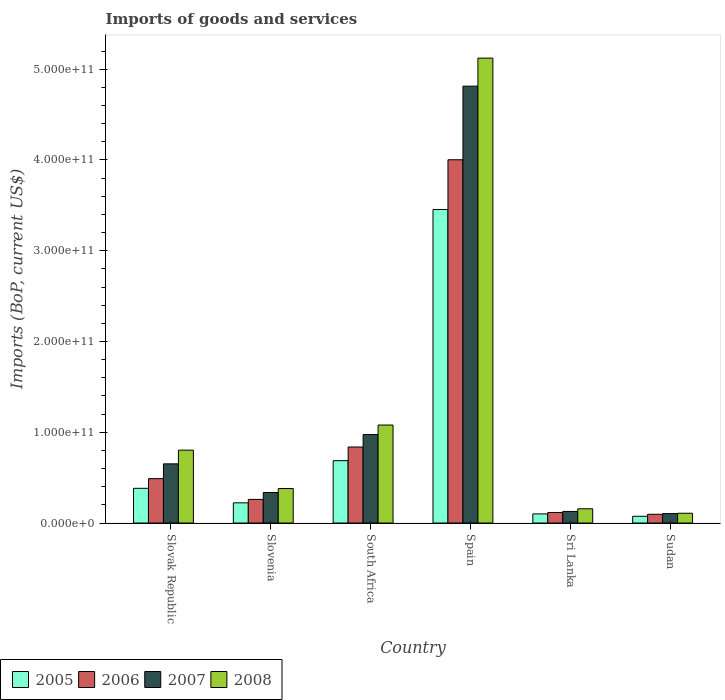How many groups of bars are there?
Ensure brevity in your answer.  6. Are the number of bars on each tick of the X-axis equal?
Provide a succinct answer. Yes. How many bars are there on the 6th tick from the left?
Your response must be concise. 4. What is the label of the 5th group of bars from the left?
Your answer should be compact. Sri Lanka. What is the amount spent on imports in 2006 in Sri Lanka?
Your answer should be very brief. 1.16e+1. Across all countries, what is the maximum amount spent on imports in 2008?
Provide a succinct answer. 5.12e+11. Across all countries, what is the minimum amount spent on imports in 2005?
Your response must be concise. 7.45e+09. In which country was the amount spent on imports in 2005 maximum?
Your response must be concise. Spain. In which country was the amount spent on imports in 2006 minimum?
Offer a very short reply. Sudan. What is the total amount spent on imports in 2008 in the graph?
Make the answer very short. 7.65e+11. What is the difference between the amount spent on imports in 2008 in South Africa and that in Sudan?
Ensure brevity in your answer.  9.72e+1. What is the difference between the amount spent on imports in 2008 in Sudan and the amount spent on imports in 2006 in Slovenia?
Offer a terse response. -1.53e+1. What is the average amount spent on imports in 2005 per country?
Your response must be concise. 8.20e+1. What is the difference between the amount spent on imports of/in 2007 and amount spent on imports of/in 2006 in Slovenia?
Provide a short and direct response. 7.59e+09. What is the ratio of the amount spent on imports in 2006 in Spain to that in Sri Lanka?
Offer a terse response. 34.44. What is the difference between the highest and the second highest amount spent on imports in 2008?
Provide a succinct answer. 4.04e+11. What is the difference between the highest and the lowest amount spent on imports in 2007?
Give a very brief answer. 4.71e+11. In how many countries, is the amount spent on imports in 2008 greater than the average amount spent on imports in 2008 taken over all countries?
Offer a terse response. 1. Is the sum of the amount spent on imports in 2006 in Slovak Republic and Sri Lanka greater than the maximum amount spent on imports in 2007 across all countries?
Keep it short and to the point. No. Is it the case that in every country, the sum of the amount spent on imports in 2008 and amount spent on imports in 2006 is greater than the sum of amount spent on imports in 2005 and amount spent on imports in 2007?
Provide a short and direct response. No. What does the 2nd bar from the right in Slovenia represents?
Provide a short and direct response. 2007. How many bars are there?
Your response must be concise. 24. Are all the bars in the graph horizontal?
Your response must be concise. No. How many countries are there in the graph?
Offer a very short reply. 6. What is the difference between two consecutive major ticks on the Y-axis?
Your answer should be very brief. 1.00e+11. Are the values on the major ticks of Y-axis written in scientific E-notation?
Your answer should be compact. Yes. How many legend labels are there?
Your response must be concise. 4. How are the legend labels stacked?
Provide a short and direct response. Horizontal. What is the title of the graph?
Provide a succinct answer. Imports of goods and services. Does "2002" appear as one of the legend labels in the graph?
Your response must be concise. No. What is the label or title of the Y-axis?
Make the answer very short. Imports (BoP, current US$). What is the Imports (BoP, current US$) in 2005 in Slovak Republic?
Your answer should be very brief. 3.82e+1. What is the Imports (BoP, current US$) of 2006 in Slovak Republic?
Your response must be concise. 4.89e+1. What is the Imports (BoP, current US$) in 2007 in Slovak Republic?
Keep it short and to the point. 6.52e+1. What is the Imports (BoP, current US$) of 2008 in Slovak Republic?
Provide a succinct answer. 8.03e+1. What is the Imports (BoP, current US$) of 2005 in Slovenia?
Make the answer very short. 2.22e+1. What is the Imports (BoP, current US$) in 2006 in Slovenia?
Ensure brevity in your answer.  2.60e+1. What is the Imports (BoP, current US$) in 2007 in Slovenia?
Your answer should be compact. 3.36e+1. What is the Imports (BoP, current US$) of 2008 in Slovenia?
Keep it short and to the point. 3.80e+1. What is the Imports (BoP, current US$) in 2005 in South Africa?
Provide a succinct answer. 6.87e+1. What is the Imports (BoP, current US$) in 2006 in South Africa?
Your answer should be compact. 8.38e+1. What is the Imports (BoP, current US$) in 2007 in South Africa?
Ensure brevity in your answer.  9.75e+1. What is the Imports (BoP, current US$) of 2008 in South Africa?
Your response must be concise. 1.08e+11. What is the Imports (BoP, current US$) in 2005 in Spain?
Offer a very short reply. 3.45e+11. What is the Imports (BoP, current US$) of 2006 in Spain?
Ensure brevity in your answer.  4.00e+11. What is the Imports (BoP, current US$) of 2007 in Spain?
Ensure brevity in your answer.  4.81e+11. What is the Imports (BoP, current US$) of 2008 in Spain?
Offer a terse response. 5.12e+11. What is the Imports (BoP, current US$) in 2005 in Sri Lanka?
Offer a terse response. 1.01e+1. What is the Imports (BoP, current US$) in 2006 in Sri Lanka?
Ensure brevity in your answer.  1.16e+1. What is the Imports (BoP, current US$) in 2007 in Sri Lanka?
Give a very brief answer. 1.28e+1. What is the Imports (BoP, current US$) of 2008 in Sri Lanka?
Offer a terse response. 1.57e+1. What is the Imports (BoP, current US$) in 2005 in Sudan?
Make the answer very short. 7.45e+09. What is the Imports (BoP, current US$) in 2006 in Sudan?
Provide a succinct answer. 9.63e+09. What is the Imports (BoP, current US$) in 2007 in Sudan?
Your answer should be compact. 1.04e+1. What is the Imports (BoP, current US$) of 2008 in Sudan?
Your answer should be very brief. 1.08e+1. Across all countries, what is the maximum Imports (BoP, current US$) of 2005?
Offer a very short reply. 3.45e+11. Across all countries, what is the maximum Imports (BoP, current US$) of 2006?
Your answer should be very brief. 4.00e+11. Across all countries, what is the maximum Imports (BoP, current US$) in 2007?
Provide a succinct answer. 4.81e+11. Across all countries, what is the maximum Imports (BoP, current US$) of 2008?
Provide a short and direct response. 5.12e+11. Across all countries, what is the minimum Imports (BoP, current US$) of 2005?
Provide a short and direct response. 7.45e+09. Across all countries, what is the minimum Imports (BoP, current US$) of 2006?
Provide a succinct answer. 9.63e+09. Across all countries, what is the minimum Imports (BoP, current US$) in 2007?
Your answer should be very brief. 1.04e+1. Across all countries, what is the minimum Imports (BoP, current US$) of 2008?
Give a very brief answer. 1.08e+1. What is the total Imports (BoP, current US$) in 2005 in the graph?
Make the answer very short. 4.92e+11. What is the total Imports (BoP, current US$) in 2006 in the graph?
Your answer should be compact. 5.80e+11. What is the total Imports (BoP, current US$) in 2007 in the graph?
Your answer should be very brief. 7.01e+11. What is the total Imports (BoP, current US$) in 2008 in the graph?
Make the answer very short. 7.65e+11. What is the difference between the Imports (BoP, current US$) of 2005 in Slovak Republic and that in Slovenia?
Make the answer very short. 1.60e+1. What is the difference between the Imports (BoP, current US$) in 2006 in Slovak Republic and that in Slovenia?
Provide a succinct answer. 2.29e+1. What is the difference between the Imports (BoP, current US$) of 2007 in Slovak Republic and that in Slovenia?
Keep it short and to the point. 3.16e+1. What is the difference between the Imports (BoP, current US$) in 2008 in Slovak Republic and that in Slovenia?
Ensure brevity in your answer.  4.23e+1. What is the difference between the Imports (BoP, current US$) of 2005 in Slovak Republic and that in South Africa?
Your response must be concise. -3.05e+1. What is the difference between the Imports (BoP, current US$) in 2006 in Slovak Republic and that in South Africa?
Give a very brief answer. -3.49e+1. What is the difference between the Imports (BoP, current US$) of 2007 in Slovak Republic and that in South Africa?
Offer a terse response. -3.23e+1. What is the difference between the Imports (BoP, current US$) of 2008 in Slovak Republic and that in South Africa?
Give a very brief answer. -2.77e+1. What is the difference between the Imports (BoP, current US$) of 2005 in Slovak Republic and that in Spain?
Give a very brief answer. -3.07e+11. What is the difference between the Imports (BoP, current US$) of 2006 in Slovak Republic and that in Spain?
Offer a very short reply. -3.51e+11. What is the difference between the Imports (BoP, current US$) in 2007 in Slovak Republic and that in Spain?
Your answer should be compact. -4.16e+11. What is the difference between the Imports (BoP, current US$) of 2008 in Slovak Republic and that in Spain?
Provide a short and direct response. -4.32e+11. What is the difference between the Imports (BoP, current US$) in 2005 in Slovak Republic and that in Sri Lanka?
Offer a very short reply. 2.82e+1. What is the difference between the Imports (BoP, current US$) in 2006 in Slovak Republic and that in Sri Lanka?
Your answer should be very brief. 3.73e+1. What is the difference between the Imports (BoP, current US$) of 2007 in Slovak Republic and that in Sri Lanka?
Keep it short and to the point. 5.24e+1. What is the difference between the Imports (BoP, current US$) of 2008 in Slovak Republic and that in Sri Lanka?
Provide a short and direct response. 6.46e+1. What is the difference between the Imports (BoP, current US$) in 2005 in Slovak Republic and that in Sudan?
Offer a terse response. 3.08e+1. What is the difference between the Imports (BoP, current US$) of 2006 in Slovak Republic and that in Sudan?
Offer a very short reply. 3.93e+1. What is the difference between the Imports (BoP, current US$) in 2007 in Slovak Republic and that in Sudan?
Ensure brevity in your answer.  5.48e+1. What is the difference between the Imports (BoP, current US$) of 2008 in Slovak Republic and that in Sudan?
Offer a terse response. 6.95e+1. What is the difference between the Imports (BoP, current US$) of 2005 in Slovenia and that in South Africa?
Offer a very short reply. -4.65e+1. What is the difference between the Imports (BoP, current US$) in 2006 in Slovenia and that in South Africa?
Give a very brief answer. -5.77e+1. What is the difference between the Imports (BoP, current US$) of 2007 in Slovenia and that in South Africa?
Keep it short and to the point. -6.39e+1. What is the difference between the Imports (BoP, current US$) of 2008 in Slovenia and that in South Africa?
Give a very brief answer. -7.00e+1. What is the difference between the Imports (BoP, current US$) in 2005 in Slovenia and that in Spain?
Your answer should be very brief. -3.23e+11. What is the difference between the Imports (BoP, current US$) in 2006 in Slovenia and that in Spain?
Your answer should be compact. -3.74e+11. What is the difference between the Imports (BoP, current US$) of 2007 in Slovenia and that in Spain?
Offer a terse response. -4.48e+11. What is the difference between the Imports (BoP, current US$) in 2008 in Slovenia and that in Spain?
Your answer should be compact. -4.74e+11. What is the difference between the Imports (BoP, current US$) in 2005 in Slovenia and that in Sri Lanka?
Ensure brevity in your answer.  1.22e+1. What is the difference between the Imports (BoP, current US$) of 2006 in Slovenia and that in Sri Lanka?
Provide a short and direct response. 1.44e+1. What is the difference between the Imports (BoP, current US$) of 2007 in Slovenia and that in Sri Lanka?
Provide a short and direct response. 2.09e+1. What is the difference between the Imports (BoP, current US$) in 2008 in Slovenia and that in Sri Lanka?
Provide a succinct answer. 2.23e+1. What is the difference between the Imports (BoP, current US$) of 2005 in Slovenia and that in Sudan?
Give a very brief answer. 1.48e+1. What is the difference between the Imports (BoP, current US$) in 2006 in Slovenia and that in Sudan?
Your answer should be very brief. 1.64e+1. What is the difference between the Imports (BoP, current US$) of 2007 in Slovenia and that in Sudan?
Your answer should be compact. 2.32e+1. What is the difference between the Imports (BoP, current US$) of 2008 in Slovenia and that in Sudan?
Ensure brevity in your answer.  2.72e+1. What is the difference between the Imports (BoP, current US$) in 2005 in South Africa and that in Spain?
Provide a short and direct response. -2.77e+11. What is the difference between the Imports (BoP, current US$) in 2006 in South Africa and that in Spain?
Ensure brevity in your answer.  -3.16e+11. What is the difference between the Imports (BoP, current US$) in 2007 in South Africa and that in Spain?
Provide a succinct answer. -3.84e+11. What is the difference between the Imports (BoP, current US$) in 2008 in South Africa and that in Spain?
Provide a short and direct response. -4.04e+11. What is the difference between the Imports (BoP, current US$) in 2005 in South Africa and that in Sri Lanka?
Provide a short and direct response. 5.87e+1. What is the difference between the Imports (BoP, current US$) in 2006 in South Africa and that in Sri Lanka?
Provide a succinct answer. 7.22e+1. What is the difference between the Imports (BoP, current US$) in 2007 in South Africa and that in Sri Lanka?
Give a very brief answer. 8.47e+1. What is the difference between the Imports (BoP, current US$) in 2008 in South Africa and that in Sri Lanka?
Your answer should be compact. 9.23e+1. What is the difference between the Imports (BoP, current US$) of 2005 in South Africa and that in Sudan?
Provide a succinct answer. 6.13e+1. What is the difference between the Imports (BoP, current US$) of 2006 in South Africa and that in Sudan?
Your answer should be compact. 7.41e+1. What is the difference between the Imports (BoP, current US$) in 2007 in South Africa and that in Sudan?
Offer a very short reply. 8.71e+1. What is the difference between the Imports (BoP, current US$) in 2008 in South Africa and that in Sudan?
Make the answer very short. 9.72e+1. What is the difference between the Imports (BoP, current US$) of 2005 in Spain and that in Sri Lanka?
Your response must be concise. 3.35e+11. What is the difference between the Imports (BoP, current US$) of 2006 in Spain and that in Sri Lanka?
Ensure brevity in your answer.  3.89e+11. What is the difference between the Imports (BoP, current US$) of 2007 in Spain and that in Sri Lanka?
Your answer should be very brief. 4.69e+11. What is the difference between the Imports (BoP, current US$) of 2008 in Spain and that in Sri Lanka?
Make the answer very short. 4.97e+11. What is the difference between the Imports (BoP, current US$) in 2005 in Spain and that in Sudan?
Your response must be concise. 3.38e+11. What is the difference between the Imports (BoP, current US$) of 2006 in Spain and that in Sudan?
Your response must be concise. 3.91e+11. What is the difference between the Imports (BoP, current US$) of 2007 in Spain and that in Sudan?
Provide a short and direct response. 4.71e+11. What is the difference between the Imports (BoP, current US$) of 2008 in Spain and that in Sudan?
Give a very brief answer. 5.01e+11. What is the difference between the Imports (BoP, current US$) in 2005 in Sri Lanka and that in Sudan?
Provide a succinct answer. 2.62e+09. What is the difference between the Imports (BoP, current US$) in 2006 in Sri Lanka and that in Sudan?
Offer a terse response. 1.99e+09. What is the difference between the Imports (BoP, current US$) in 2007 in Sri Lanka and that in Sudan?
Provide a succinct answer. 2.36e+09. What is the difference between the Imports (BoP, current US$) of 2008 in Sri Lanka and that in Sudan?
Keep it short and to the point. 4.93e+09. What is the difference between the Imports (BoP, current US$) of 2005 in Slovak Republic and the Imports (BoP, current US$) of 2006 in Slovenia?
Offer a terse response. 1.22e+1. What is the difference between the Imports (BoP, current US$) in 2005 in Slovak Republic and the Imports (BoP, current US$) in 2007 in Slovenia?
Your response must be concise. 4.62e+09. What is the difference between the Imports (BoP, current US$) of 2005 in Slovak Republic and the Imports (BoP, current US$) of 2008 in Slovenia?
Provide a short and direct response. 2.41e+08. What is the difference between the Imports (BoP, current US$) in 2006 in Slovak Republic and the Imports (BoP, current US$) in 2007 in Slovenia?
Make the answer very short. 1.53e+1. What is the difference between the Imports (BoP, current US$) in 2006 in Slovak Republic and the Imports (BoP, current US$) in 2008 in Slovenia?
Your answer should be very brief. 1.09e+1. What is the difference between the Imports (BoP, current US$) of 2007 in Slovak Republic and the Imports (BoP, current US$) of 2008 in Slovenia?
Your response must be concise. 2.72e+1. What is the difference between the Imports (BoP, current US$) of 2005 in Slovak Republic and the Imports (BoP, current US$) of 2006 in South Africa?
Your answer should be very brief. -4.55e+1. What is the difference between the Imports (BoP, current US$) in 2005 in Slovak Republic and the Imports (BoP, current US$) in 2007 in South Africa?
Give a very brief answer. -5.93e+1. What is the difference between the Imports (BoP, current US$) of 2005 in Slovak Republic and the Imports (BoP, current US$) of 2008 in South Africa?
Offer a terse response. -6.97e+1. What is the difference between the Imports (BoP, current US$) in 2006 in Slovak Republic and the Imports (BoP, current US$) in 2007 in South Africa?
Keep it short and to the point. -4.86e+1. What is the difference between the Imports (BoP, current US$) in 2006 in Slovak Republic and the Imports (BoP, current US$) in 2008 in South Africa?
Make the answer very short. -5.91e+1. What is the difference between the Imports (BoP, current US$) of 2007 in Slovak Republic and the Imports (BoP, current US$) of 2008 in South Africa?
Provide a succinct answer. -4.28e+1. What is the difference between the Imports (BoP, current US$) in 2005 in Slovak Republic and the Imports (BoP, current US$) in 2006 in Spain?
Give a very brief answer. -3.62e+11. What is the difference between the Imports (BoP, current US$) of 2005 in Slovak Republic and the Imports (BoP, current US$) of 2007 in Spain?
Your response must be concise. -4.43e+11. What is the difference between the Imports (BoP, current US$) of 2005 in Slovak Republic and the Imports (BoP, current US$) of 2008 in Spain?
Provide a succinct answer. -4.74e+11. What is the difference between the Imports (BoP, current US$) in 2006 in Slovak Republic and the Imports (BoP, current US$) in 2007 in Spain?
Give a very brief answer. -4.32e+11. What is the difference between the Imports (BoP, current US$) in 2006 in Slovak Republic and the Imports (BoP, current US$) in 2008 in Spain?
Give a very brief answer. -4.63e+11. What is the difference between the Imports (BoP, current US$) of 2007 in Slovak Republic and the Imports (BoP, current US$) of 2008 in Spain?
Provide a succinct answer. -4.47e+11. What is the difference between the Imports (BoP, current US$) of 2005 in Slovak Republic and the Imports (BoP, current US$) of 2006 in Sri Lanka?
Your answer should be very brief. 2.66e+1. What is the difference between the Imports (BoP, current US$) in 2005 in Slovak Republic and the Imports (BoP, current US$) in 2007 in Sri Lanka?
Give a very brief answer. 2.55e+1. What is the difference between the Imports (BoP, current US$) of 2005 in Slovak Republic and the Imports (BoP, current US$) of 2008 in Sri Lanka?
Your answer should be compact. 2.26e+1. What is the difference between the Imports (BoP, current US$) of 2006 in Slovak Republic and the Imports (BoP, current US$) of 2007 in Sri Lanka?
Keep it short and to the point. 3.61e+1. What is the difference between the Imports (BoP, current US$) in 2006 in Slovak Republic and the Imports (BoP, current US$) in 2008 in Sri Lanka?
Your answer should be very brief. 3.32e+1. What is the difference between the Imports (BoP, current US$) of 2007 in Slovak Republic and the Imports (BoP, current US$) of 2008 in Sri Lanka?
Offer a terse response. 4.95e+1. What is the difference between the Imports (BoP, current US$) of 2005 in Slovak Republic and the Imports (BoP, current US$) of 2006 in Sudan?
Your answer should be compact. 2.86e+1. What is the difference between the Imports (BoP, current US$) of 2005 in Slovak Republic and the Imports (BoP, current US$) of 2007 in Sudan?
Your answer should be very brief. 2.78e+1. What is the difference between the Imports (BoP, current US$) of 2005 in Slovak Republic and the Imports (BoP, current US$) of 2008 in Sudan?
Your answer should be very brief. 2.75e+1. What is the difference between the Imports (BoP, current US$) of 2006 in Slovak Republic and the Imports (BoP, current US$) of 2007 in Sudan?
Make the answer very short. 3.85e+1. What is the difference between the Imports (BoP, current US$) in 2006 in Slovak Republic and the Imports (BoP, current US$) in 2008 in Sudan?
Offer a terse response. 3.81e+1. What is the difference between the Imports (BoP, current US$) of 2007 in Slovak Republic and the Imports (BoP, current US$) of 2008 in Sudan?
Your answer should be very brief. 5.44e+1. What is the difference between the Imports (BoP, current US$) in 2005 in Slovenia and the Imports (BoP, current US$) in 2006 in South Africa?
Your answer should be very brief. -6.15e+1. What is the difference between the Imports (BoP, current US$) of 2005 in Slovenia and the Imports (BoP, current US$) of 2007 in South Africa?
Provide a short and direct response. -7.53e+1. What is the difference between the Imports (BoP, current US$) of 2005 in Slovenia and the Imports (BoP, current US$) of 2008 in South Africa?
Your answer should be compact. -8.57e+1. What is the difference between the Imports (BoP, current US$) in 2006 in Slovenia and the Imports (BoP, current US$) in 2007 in South Africa?
Ensure brevity in your answer.  -7.15e+1. What is the difference between the Imports (BoP, current US$) in 2006 in Slovenia and the Imports (BoP, current US$) in 2008 in South Africa?
Offer a terse response. -8.19e+1. What is the difference between the Imports (BoP, current US$) of 2007 in Slovenia and the Imports (BoP, current US$) of 2008 in South Africa?
Give a very brief answer. -7.43e+1. What is the difference between the Imports (BoP, current US$) of 2005 in Slovenia and the Imports (BoP, current US$) of 2006 in Spain?
Make the answer very short. -3.78e+11. What is the difference between the Imports (BoP, current US$) in 2005 in Slovenia and the Imports (BoP, current US$) in 2007 in Spain?
Keep it short and to the point. -4.59e+11. What is the difference between the Imports (BoP, current US$) in 2005 in Slovenia and the Imports (BoP, current US$) in 2008 in Spain?
Give a very brief answer. -4.90e+11. What is the difference between the Imports (BoP, current US$) in 2006 in Slovenia and the Imports (BoP, current US$) in 2007 in Spain?
Provide a succinct answer. -4.55e+11. What is the difference between the Imports (BoP, current US$) of 2006 in Slovenia and the Imports (BoP, current US$) of 2008 in Spain?
Your answer should be very brief. -4.86e+11. What is the difference between the Imports (BoP, current US$) in 2007 in Slovenia and the Imports (BoP, current US$) in 2008 in Spain?
Keep it short and to the point. -4.79e+11. What is the difference between the Imports (BoP, current US$) of 2005 in Slovenia and the Imports (BoP, current US$) of 2006 in Sri Lanka?
Your answer should be compact. 1.06e+1. What is the difference between the Imports (BoP, current US$) of 2005 in Slovenia and the Imports (BoP, current US$) of 2007 in Sri Lanka?
Keep it short and to the point. 9.48e+09. What is the difference between the Imports (BoP, current US$) of 2005 in Slovenia and the Imports (BoP, current US$) of 2008 in Sri Lanka?
Provide a short and direct response. 6.56e+09. What is the difference between the Imports (BoP, current US$) in 2006 in Slovenia and the Imports (BoP, current US$) in 2007 in Sri Lanka?
Your answer should be compact. 1.33e+1. What is the difference between the Imports (BoP, current US$) of 2006 in Slovenia and the Imports (BoP, current US$) of 2008 in Sri Lanka?
Your answer should be compact. 1.03e+1. What is the difference between the Imports (BoP, current US$) of 2007 in Slovenia and the Imports (BoP, current US$) of 2008 in Sri Lanka?
Provide a short and direct response. 1.79e+1. What is the difference between the Imports (BoP, current US$) in 2005 in Slovenia and the Imports (BoP, current US$) in 2006 in Sudan?
Offer a terse response. 1.26e+1. What is the difference between the Imports (BoP, current US$) in 2005 in Slovenia and the Imports (BoP, current US$) in 2007 in Sudan?
Keep it short and to the point. 1.18e+1. What is the difference between the Imports (BoP, current US$) of 2005 in Slovenia and the Imports (BoP, current US$) of 2008 in Sudan?
Your response must be concise. 1.15e+1. What is the difference between the Imports (BoP, current US$) of 2006 in Slovenia and the Imports (BoP, current US$) of 2007 in Sudan?
Offer a terse response. 1.56e+1. What is the difference between the Imports (BoP, current US$) in 2006 in Slovenia and the Imports (BoP, current US$) in 2008 in Sudan?
Provide a succinct answer. 1.53e+1. What is the difference between the Imports (BoP, current US$) in 2007 in Slovenia and the Imports (BoP, current US$) in 2008 in Sudan?
Provide a succinct answer. 2.29e+1. What is the difference between the Imports (BoP, current US$) in 2005 in South Africa and the Imports (BoP, current US$) in 2006 in Spain?
Keep it short and to the point. -3.32e+11. What is the difference between the Imports (BoP, current US$) of 2005 in South Africa and the Imports (BoP, current US$) of 2007 in Spain?
Give a very brief answer. -4.13e+11. What is the difference between the Imports (BoP, current US$) of 2005 in South Africa and the Imports (BoP, current US$) of 2008 in Spain?
Provide a short and direct response. -4.44e+11. What is the difference between the Imports (BoP, current US$) in 2006 in South Africa and the Imports (BoP, current US$) in 2007 in Spain?
Make the answer very short. -3.98e+11. What is the difference between the Imports (BoP, current US$) of 2006 in South Africa and the Imports (BoP, current US$) of 2008 in Spain?
Your answer should be very brief. -4.28e+11. What is the difference between the Imports (BoP, current US$) in 2007 in South Africa and the Imports (BoP, current US$) in 2008 in Spain?
Provide a short and direct response. -4.15e+11. What is the difference between the Imports (BoP, current US$) in 2005 in South Africa and the Imports (BoP, current US$) in 2006 in Sri Lanka?
Make the answer very short. 5.71e+1. What is the difference between the Imports (BoP, current US$) of 2005 in South Africa and the Imports (BoP, current US$) of 2007 in Sri Lanka?
Your response must be concise. 5.60e+1. What is the difference between the Imports (BoP, current US$) of 2005 in South Africa and the Imports (BoP, current US$) of 2008 in Sri Lanka?
Make the answer very short. 5.30e+1. What is the difference between the Imports (BoP, current US$) in 2006 in South Africa and the Imports (BoP, current US$) in 2007 in Sri Lanka?
Make the answer very short. 7.10e+1. What is the difference between the Imports (BoP, current US$) of 2006 in South Africa and the Imports (BoP, current US$) of 2008 in Sri Lanka?
Give a very brief answer. 6.81e+1. What is the difference between the Imports (BoP, current US$) of 2007 in South Africa and the Imports (BoP, current US$) of 2008 in Sri Lanka?
Provide a succinct answer. 8.18e+1. What is the difference between the Imports (BoP, current US$) in 2005 in South Africa and the Imports (BoP, current US$) in 2006 in Sudan?
Give a very brief answer. 5.91e+1. What is the difference between the Imports (BoP, current US$) of 2005 in South Africa and the Imports (BoP, current US$) of 2007 in Sudan?
Your answer should be compact. 5.83e+1. What is the difference between the Imports (BoP, current US$) of 2005 in South Africa and the Imports (BoP, current US$) of 2008 in Sudan?
Your response must be concise. 5.80e+1. What is the difference between the Imports (BoP, current US$) in 2006 in South Africa and the Imports (BoP, current US$) in 2007 in Sudan?
Your answer should be compact. 7.34e+1. What is the difference between the Imports (BoP, current US$) in 2006 in South Africa and the Imports (BoP, current US$) in 2008 in Sudan?
Offer a terse response. 7.30e+1. What is the difference between the Imports (BoP, current US$) in 2007 in South Africa and the Imports (BoP, current US$) in 2008 in Sudan?
Make the answer very short. 8.67e+1. What is the difference between the Imports (BoP, current US$) of 2005 in Spain and the Imports (BoP, current US$) of 2006 in Sri Lanka?
Your answer should be compact. 3.34e+11. What is the difference between the Imports (BoP, current US$) in 2005 in Spain and the Imports (BoP, current US$) in 2007 in Sri Lanka?
Provide a short and direct response. 3.33e+11. What is the difference between the Imports (BoP, current US$) in 2005 in Spain and the Imports (BoP, current US$) in 2008 in Sri Lanka?
Provide a succinct answer. 3.30e+11. What is the difference between the Imports (BoP, current US$) in 2006 in Spain and the Imports (BoP, current US$) in 2007 in Sri Lanka?
Provide a succinct answer. 3.87e+11. What is the difference between the Imports (BoP, current US$) of 2006 in Spain and the Imports (BoP, current US$) of 2008 in Sri Lanka?
Give a very brief answer. 3.85e+11. What is the difference between the Imports (BoP, current US$) of 2007 in Spain and the Imports (BoP, current US$) of 2008 in Sri Lanka?
Keep it short and to the point. 4.66e+11. What is the difference between the Imports (BoP, current US$) in 2005 in Spain and the Imports (BoP, current US$) in 2006 in Sudan?
Provide a succinct answer. 3.36e+11. What is the difference between the Imports (BoP, current US$) of 2005 in Spain and the Imports (BoP, current US$) of 2007 in Sudan?
Your answer should be compact. 3.35e+11. What is the difference between the Imports (BoP, current US$) in 2005 in Spain and the Imports (BoP, current US$) in 2008 in Sudan?
Keep it short and to the point. 3.35e+11. What is the difference between the Imports (BoP, current US$) of 2006 in Spain and the Imports (BoP, current US$) of 2007 in Sudan?
Keep it short and to the point. 3.90e+11. What is the difference between the Imports (BoP, current US$) of 2006 in Spain and the Imports (BoP, current US$) of 2008 in Sudan?
Give a very brief answer. 3.89e+11. What is the difference between the Imports (BoP, current US$) in 2007 in Spain and the Imports (BoP, current US$) in 2008 in Sudan?
Your response must be concise. 4.71e+11. What is the difference between the Imports (BoP, current US$) of 2005 in Sri Lanka and the Imports (BoP, current US$) of 2006 in Sudan?
Your answer should be compact. 4.35e+08. What is the difference between the Imports (BoP, current US$) of 2005 in Sri Lanka and the Imports (BoP, current US$) of 2007 in Sudan?
Ensure brevity in your answer.  -3.38e+08. What is the difference between the Imports (BoP, current US$) of 2005 in Sri Lanka and the Imports (BoP, current US$) of 2008 in Sudan?
Provide a succinct answer. -6.96e+08. What is the difference between the Imports (BoP, current US$) in 2006 in Sri Lanka and the Imports (BoP, current US$) in 2007 in Sudan?
Your answer should be compact. 1.22e+09. What is the difference between the Imports (BoP, current US$) in 2006 in Sri Lanka and the Imports (BoP, current US$) in 2008 in Sudan?
Ensure brevity in your answer.  8.60e+08. What is the difference between the Imports (BoP, current US$) of 2007 in Sri Lanka and the Imports (BoP, current US$) of 2008 in Sudan?
Provide a short and direct response. 2.01e+09. What is the average Imports (BoP, current US$) of 2005 per country?
Keep it short and to the point. 8.20e+1. What is the average Imports (BoP, current US$) of 2006 per country?
Provide a succinct answer. 9.67e+1. What is the average Imports (BoP, current US$) of 2007 per country?
Offer a terse response. 1.17e+11. What is the average Imports (BoP, current US$) of 2008 per country?
Offer a very short reply. 1.27e+11. What is the difference between the Imports (BoP, current US$) of 2005 and Imports (BoP, current US$) of 2006 in Slovak Republic?
Your response must be concise. -1.07e+1. What is the difference between the Imports (BoP, current US$) in 2005 and Imports (BoP, current US$) in 2007 in Slovak Republic?
Your response must be concise. -2.70e+1. What is the difference between the Imports (BoP, current US$) of 2005 and Imports (BoP, current US$) of 2008 in Slovak Republic?
Your answer should be very brief. -4.20e+1. What is the difference between the Imports (BoP, current US$) in 2006 and Imports (BoP, current US$) in 2007 in Slovak Republic?
Your answer should be compact. -1.63e+1. What is the difference between the Imports (BoP, current US$) in 2006 and Imports (BoP, current US$) in 2008 in Slovak Republic?
Offer a terse response. -3.14e+1. What is the difference between the Imports (BoP, current US$) in 2007 and Imports (BoP, current US$) in 2008 in Slovak Republic?
Ensure brevity in your answer.  -1.51e+1. What is the difference between the Imports (BoP, current US$) of 2005 and Imports (BoP, current US$) of 2006 in Slovenia?
Ensure brevity in your answer.  -3.79e+09. What is the difference between the Imports (BoP, current US$) of 2005 and Imports (BoP, current US$) of 2007 in Slovenia?
Offer a terse response. -1.14e+1. What is the difference between the Imports (BoP, current US$) in 2005 and Imports (BoP, current US$) in 2008 in Slovenia?
Your response must be concise. -1.58e+1. What is the difference between the Imports (BoP, current US$) of 2006 and Imports (BoP, current US$) of 2007 in Slovenia?
Offer a very short reply. -7.59e+09. What is the difference between the Imports (BoP, current US$) in 2006 and Imports (BoP, current US$) in 2008 in Slovenia?
Provide a short and direct response. -1.20e+1. What is the difference between the Imports (BoP, current US$) in 2007 and Imports (BoP, current US$) in 2008 in Slovenia?
Your answer should be compact. -4.38e+09. What is the difference between the Imports (BoP, current US$) of 2005 and Imports (BoP, current US$) of 2006 in South Africa?
Offer a terse response. -1.50e+1. What is the difference between the Imports (BoP, current US$) of 2005 and Imports (BoP, current US$) of 2007 in South Africa?
Keep it short and to the point. -2.88e+1. What is the difference between the Imports (BoP, current US$) of 2005 and Imports (BoP, current US$) of 2008 in South Africa?
Give a very brief answer. -3.93e+1. What is the difference between the Imports (BoP, current US$) in 2006 and Imports (BoP, current US$) in 2007 in South Africa?
Make the answer very short. -1.37e+1. What is the difference between the Imports (BoP, current US$) in 2006 and Imports (BoP, current US$) in 2008 in South Africa?
Your answer should be very brief. -2.42e+1. What is the difference between the Imports (BoP, current US$) of 2007 and Imports (BoP, current US$) of 2008 in South Africa?
Provide a succinct answer. -1.05e+1. What is the difference between the Imports (BoP, current US$) in 2005 and Imports (BoP, current US$) in 2006 in Spain?
Offer a terse response. -5.48e+1. What is the difference between the Imports (BoP, current US$) of 2005 and Imports (BoP, current US$) of 2007 in Spain?
Offer a very short reply. -1.36e+11. What is the difference between the Imports (BoP, current US$) of 2005 and Imports (BoP, current US$) of 2008 in Spain?
Your response must be concise. -1.67e+11. What is the difference between the Imports (BoP, current US$) in 2006 and Imports (BoP, current US$) in 2007 in Spain?
Provide a succinct answer. -8.11e+1. What is the difference between the Imports (BoP, current US$) of 2006 and Imports (BoP, current US$) of 2008 in Spain?
Provide a succinct answer. -1.12e+11. What is the difference between the Imports (BoP, current US$) in 2007 and Imports (BoP, current US$) in 2008 in Spain?
Keep it short and to the point. -3.09e+1. What is the difference between the Imports (BoP, current US$) in 2005 and Imports (BoP, current US$) in 2006 in Sri Lanka?
Offer a terse response. -1.56e+09. What is the difference between the Imports (BoP, current US$) in 2005 and Imports (BoP, current US$) in 2007 in Sri Lanka?
Offer a very short reply. -2.70e+09. What is the difference between the Imports (BoP, current US$) in 2005 and Imports (BoP, current US$) in 2008 in Sri Lanka?
Your response must be concise. -5.63e+09. What is the difference between the Imports (BoP, current US$) in 2006 and Imports (BoP, current US$) in 2007 in Sri Lanka?
Give a very brief answer. -1.15e+09. What is the difference between the Imports (BoP, current US$) of 2006 and Imports (BoP, current US$) of 2008 in Sri Lanka?
Keep it short and to the point. -4.07e+09. What is the difference between the Imports (BoP, current US$) in 2007 and Imports (BoP, current US$) in 2008 in Sri Lanka?
Offer a terse response. -2.92e+09. What is the difference between the Imports (BoP, current US$) in 2005 and Imports (BoP, current US$) in 2006 in Sudan?
Your response must be concise. -2.18e+09. What is the difference between the Imports (BoP, current US$) of 2005 and Imports (BoP, current US$) of 2007 in Sudan?
Ensure brevity in your answer.  -2.95e+09. What is the difference between the Imports (BoP, current US$) in 2005 and Imports (BoP, current US$) in 2008 in Sudan?
Ensure brevity in your answer.  -3.31e+09. What is the difference between the Imports (BoP, current US$) of 2006 and Imports (BoP, current US$) of 2007 in Sudan?
Ensure brevity in your answer.  -7.73e+08. What is the difference between the Imports (BoP, current US$) in 2006 and Imports (BoP, current US$) in 2008 in Sudan?
Your response must be concise. -1.13e+09. What is the difference between the Imports (BoP, current US$) of 2007 and Imports (BoP, current US$) of 2008 in Sudan?
Give a very brief answer. -3.58e+08. What is the ratio of the Imports (BoP, current US$) of 2005 in Slovak Republic to that in Slovenia?
Give a very brief answer. 1.72. What is the ratio of the Imports (BoP, current US$) of 2006 in Slovak Republic to that in Slovenia?
Give a very brief answer. 1.88. What is the ratio of the Imports (BoP, current US$) in 2007 in Slovak Republic to that in Slovenia?
Keep it short and to the point. 1.94. What is the ratio of the Imports (BoP, current US$) of 2008 in Slovak Republic to that in Slovenia?
Offer a terse response. 2.11. What is the ratio of the Imports (BoP, current US$) of 2005 in Slovak Republic to that in South Africa?
Provide a succinct answer. 0.56. What is the ratio of the Imports (BoP, current US$) of 2006 in Slovak Republic to that in South Africa?
Give a very brief answer. 0.58. What is the ratio of the Imports (BoP, current US$) of 2007 in Slovak Republic to that in South Africa?
Your response must be concise. 0.67. What is the ratio of the Imports (BoP, current US$) in 2008 in Slovak Republic to that in South Africa?
Your answer should be compact. 0.74. What is the ratio of the Imports (BoP, current US$) in 2005 in Slovak Republic to that in Spain?
Provide a succinct answer. 0.11. What is the ratio of the Imports (BoP, current US$) in 2006 in Slovak Republic to that in Spain?
Your response must be concise. 0.12. What is the ratio of the Imports (BoP, current US$) in 2007 in Slovak Republic to that in Spain?
Your answer should be very brief. 0.14. What is the ratio of the Imports (BoP, current US$) of 2008 in Slovak Republic to that in Spain?
Make the answer very short. 0.16. What is the ratio of the Imports (BoP, current US$) in 2005 in Slovak Republic to that in Sri Lanka?
Give a very brief answer. 3.8. What is the ratio of the Imports (BoP, current US$) of 2006 in Slovak Republic to that in Sri Lanka?
Provide a succinct answer. 4.21. What is the ratio of the Imports (BoP, current US$) of 2007 in Slovak Republic to that in Sri Lanka?
Offer a terse response. 5.11. What is the ratio of the Imports (BoP, current US$) in 2008 in Slovak Republic to that in Sri Lanka?
Ensure brevity in your answer.  5.12. What is the ratio of the Imports (BoP, current US$) in 2005 in Slovak Republic to that in Sudan?
Provide a short and direct response. 5.13. What is the ratio of the Imports (BoP, current US$) of 2006 in Slovak Republic to that in Sudan?
Ensure brevity in your answer.  5.08. What is the ratio of the Imports (BoP, current US$) of 2007 in Slovak Republic to that in Sudan?
Offer a very short reply. 6.27. What is the ratio of the Imports (BoP, current US$) in 2008 in Slovak Republic to that in Sudan?
Ensure brevity in your answer.  7.46. What is the ratio of the Imports (BoP, current US$) of 2005 in Slovenia to that in South Africa?
Offer a terse response. 0.32. What is the ratio of the Imports (BoP, current US$) in 2006 in Slovenia to that in South Africa?
Offer a very short reply. 0.31. What is the ratio of the Imports (BoP, current US$) of 2007 in Slovenia to that in South Africa?
Give a very brief answer. 0.34. What is the ratio of the Imports (BoP, current US$) of 2008 in Slovenia to that in South Africa?
Your answer should be compact. 0.35. What is the ratio of the Imports (BoP, current US$) of 2005 in Slovenia to that in Spain?
Give a very brief answer. 0.06. What is the ratio of the Imports (BoP, current US$) in 2006 in Slovenia to that in Spain?
Provide a short and direct response. 0.07. What is the ratio of the Imports (BoP, current US$) in 2007 in Slovenia to that in Spain?
Offer a terse response. 0.07. What is the ratio of the Imports (BoP, current US$) in 2008 in Slovenia to that in Spain?
Offer a very short reply. 0.07. What is the ratio of the Imports (BoP, current US$) of 2005 in Slovenia to that in Sri Lanka?
Offer a terse response. 2.21. What is the ratio of the Imports (BoP, current US$) of 2006 in Slovenia to that in Sri Lanka?
Offer a very short reply. 2.24. What is the ratio of the Imports (BoP, current US$) of 2007 in Slovenia to that in Sri Lanka?
Offer a terse response. 2.63. What is the ratio of the Imports (BoP, current US$) in 2008 in Slovenia to that in Sri Lanka?
Make the answer very short. 2.42. What is the ratio of the Imports (BoP, current US$) of 2005 in Slovenia to that in Sudan?
Your answer should be compact. 2.99. What is the ratio of the Imports (BoP, current US$) in 2006 in Slovenia to that in Sudan?
Your answer should be compact. 2.7. What is the ratio of the Imports (BoP, current US$) in 2007 in Slovenia to that in Sudan?
Ensure brevity in your answer.  3.23. What is the ratio of the Imports (BoP, current US$) of 2008 in Slovenia to that in Sudan?
Offer a terse response. 3.53. What is the ratio of the Imports (BoP, current US$) of 2005 in South Africa to that in Spain?
Your response must be concise. 0.2. What is the ratio of the Imports (BoP, current US$) of 2006 in South Africa to that in Spain?
Give a very brief answer. 0.21. What is the ratio of the Imports (BoP, current US$) in 2007 in South Africa to that in Spain?
Your response must be concise. 0.2. What is the ratio of the Imports (BoP, current US$) in 2008 in South Africa to that in Spain?
Your answer should be compact. 0.21. What is the ratio of the Imports (BoP, current US$) in 2005 in South Africa to that in Sri Lanka?
Offer a terse response. 6.83. What is the ratio of the Imports (BoP, current US$) in 2006 in South Africa to that in Sri Lanka?
Keep it short and to the point. 7.21. What is the ratio of the Imports (BoP, current US$) in 2007 in South Africa to that in Sri Lanka?
Ensure brevity in your answer.  7.64. What is the ratio of the Imports (BoP, current US$) in 2008 in South Africa to that in Sri Lanka?
Your response must be concise. 6.88. What is the ratio of the Imports (BoP, current US$) in 2005 in South Africa to that in Sudan?
Keep it short and to the point. 9.23. What is the ratio of the Imports (BoP, current US$) of 2006 in South Africa to that in Sudan?
Offer a terse response. 8.7. What is the ratio of the Imports (BoP, current US$) in 2007 in South Africa to that in Sudan?
Your answer should be very brief. 9.37. What is the ratio of the Imports (BoP, current US$) of 2008 in South Africa to that in Sudan?
Provide a succinct answer. 10.03. What is the ratio of the Imports (BoP, current US$) of 2005 in Spain to that in Sri Lanka?
Offer a very short reply. 34.32. What is the ratio of the Imports (BoP, current US$) in 2006 in Spain to that in Sri Lanka?
Provide a short and direct response. 34.44. What is the ratio of the Imports (BoP, current US$) in 2007 in Spain to that in Sri Lanka?
Offer a very short reply. 37.7. What is the ratio of the Imports (BoP, current US$) in 2008 in Spain to that in Sri Lanka?
Provide a short and direct response. 32.64. What is the ratio of the Imports (BoP, current US$) in 2005 in Spain to that in Sudan?
Your answer should be very brief. 46.37. What is the ratio of the Imports (BoP, current US$) of 2006 in Spain to that in Sudan?
Offer a very short reply. 41.56. What is the ratio of the Imports (BoP, current US$) of 2007 in Spain to that in Sudan?
Provide a succinct answer. 46.27. What is the ratio of the Imports (BoP, current US$) in 2008 in Spain to that in Sudan?
Your answer should be very brief. 47.6. What is the ratio of the Imports (BoP, current US$) of 2005 in Sri Lanka to that in Sudan?
Provide a succinct answer. 1.35. What is the ratio of the Imports (BoP, current US$) of 2006 in Sri Lanka to that in Sudan?
Make the answer very short. 1.21. What is the ratio of the Imports (BoP, current US$) in 2007 in Sri Lanka to that in Sudan?
Keep it short and to the point. 1.23. What is the ratio of the Imports (BoP, current US$) of 2008 in Sri Lanka to that in Sudan?
Your answer should be very brief. 1.46. What is the difference between the highest and the second highest Imports (BoP, current US$) in 2005?
Your answer should be very brief. 2.77e+11. What is the difference between the highest and the second highest Imports (BoP, current US$) in 2006?
Provide a short and direct response. 3.16e+11. What is the difference between the highest and the second highest Imports (BoP, current US$) of 2007?
Offer a terse response. 3.84e+11. What is the difference between the highest and the second highest Imports (BoP, current US$) in 2008?
Provide a succinct answer. 4.04e+11. What is the difference between the highest and the lowest Imports (BoP, current US$) of 2005?
Your answer should be compact. 3.38e+11. What is the difference between the highest and the lowest Imports (BoP, current US$) in 2006?
Provide a short and direct response. 3.91e+11. What is the difference between the highest and the lowest Imports (BoP, current US$) of 2007?
Offer a very short reply. 4.71e+11. What is the difference between the highest and the lowest Imports (BoP, current US$) of 2008?
Make the answer very short. 5.01e+11. 